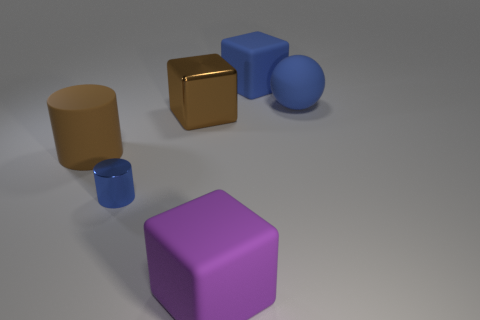Is the large purple object the same shape as the brown matte thing?
Provide a short and direct response. No. What size is the brown thing to the left of the block on the left side of the rubber thing that is in front of the big rubber cylinder?
Offer a terse response. Large. What material is the small blue cylinder?
Provide a succinct answer. Metal. What is the size of the rubber cube that is the same color as the tiny object?
Ensure brevity in your answer.  Large. There is a tiny metallic thing; is its shape the same as the big rubber object that is on the left side of the tiny blue cylinder?
Make the answer very short. Yes. What material is the thing to the right of the large cube behind the large blue thing that is to the right of the blue matte cube?
Your answer should be compact. Rubber. How many purple matte cubes are there?
Your response must be concise. 1. What number of purple objects are large metallic cubes or large rubber objects?
Give a very brief answer. 1. What number of other things are the same shape as the large brown matte thing?
Your answer should be very brief. 1. There is a big rubber object that is on the left side of the small cylinder; is it the same color as the big block that is left of the large purple thing?
Your answer should be very brief. Yes. 